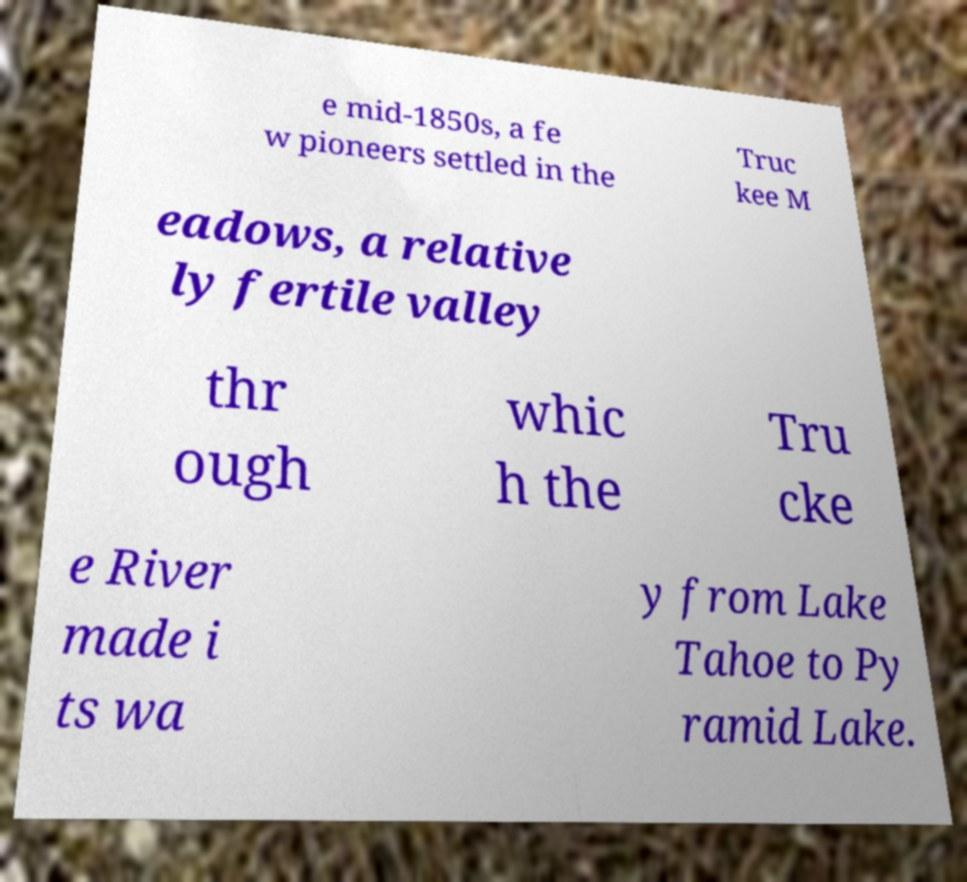Could you assist in decoding the text presented in this image and type it out clearly? e mid-1850s, a fe w pioneers settled in the Truc kee M eadows, a relative ly fertile valley thr ough whic h the Tru cke e River made i ts wa y from Lake Tahoe to Py ramid Lake. 